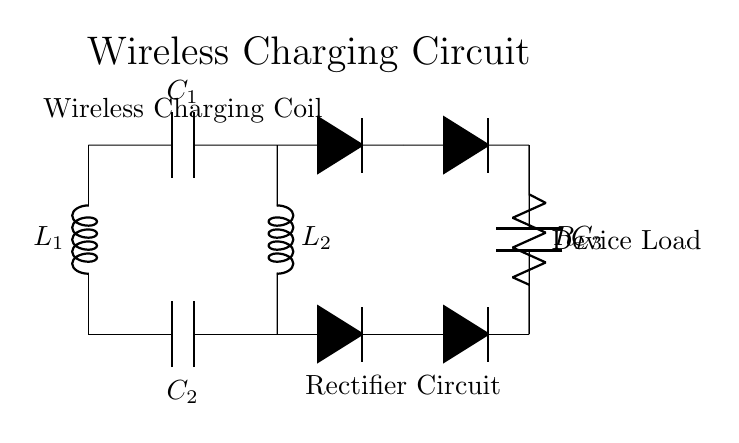What components are used in the wireless charging coil? The circuit shows two inductors labeled L1 and L2, and two capacitors labeled C1 and C2. These represent the components of the wireless charging coil section.
Answer: L1, L2, C1, C2 What type of circuit is this? The circuit diagram consists of a wireless charging coil connected to a rectifier circuit, making it a circuit for wireless charging of devices.
Answer: Wireless charging circuit How many diodes are included in the rectifier circuit? There are four diodes indicated by the symbol D, as shown in two pairs in the rectifier section of the circuit.
Answer: Four What is the purpose of capacitor C3? Capacitor C3 in this circuit functions as a smoothing capacitor, which helps filter out voltage fluctuations after the AC signal has been rectified to DC.
Answer: Smoothing capacitor What is the load connected in this circuit? The resistive load is represented by R_L, which is where the power is delivered from the circuit to the device being charged.
Answer: R_L Explain the role of L1 and L2 in this circuit. L1 and L2 are inductors that are part of the wireless charging coil and create a magnetic field that transfers energy wirelessly between the transmitter and receiver coils, enabling the charging process.
Answer: Inductors for energy transfer 